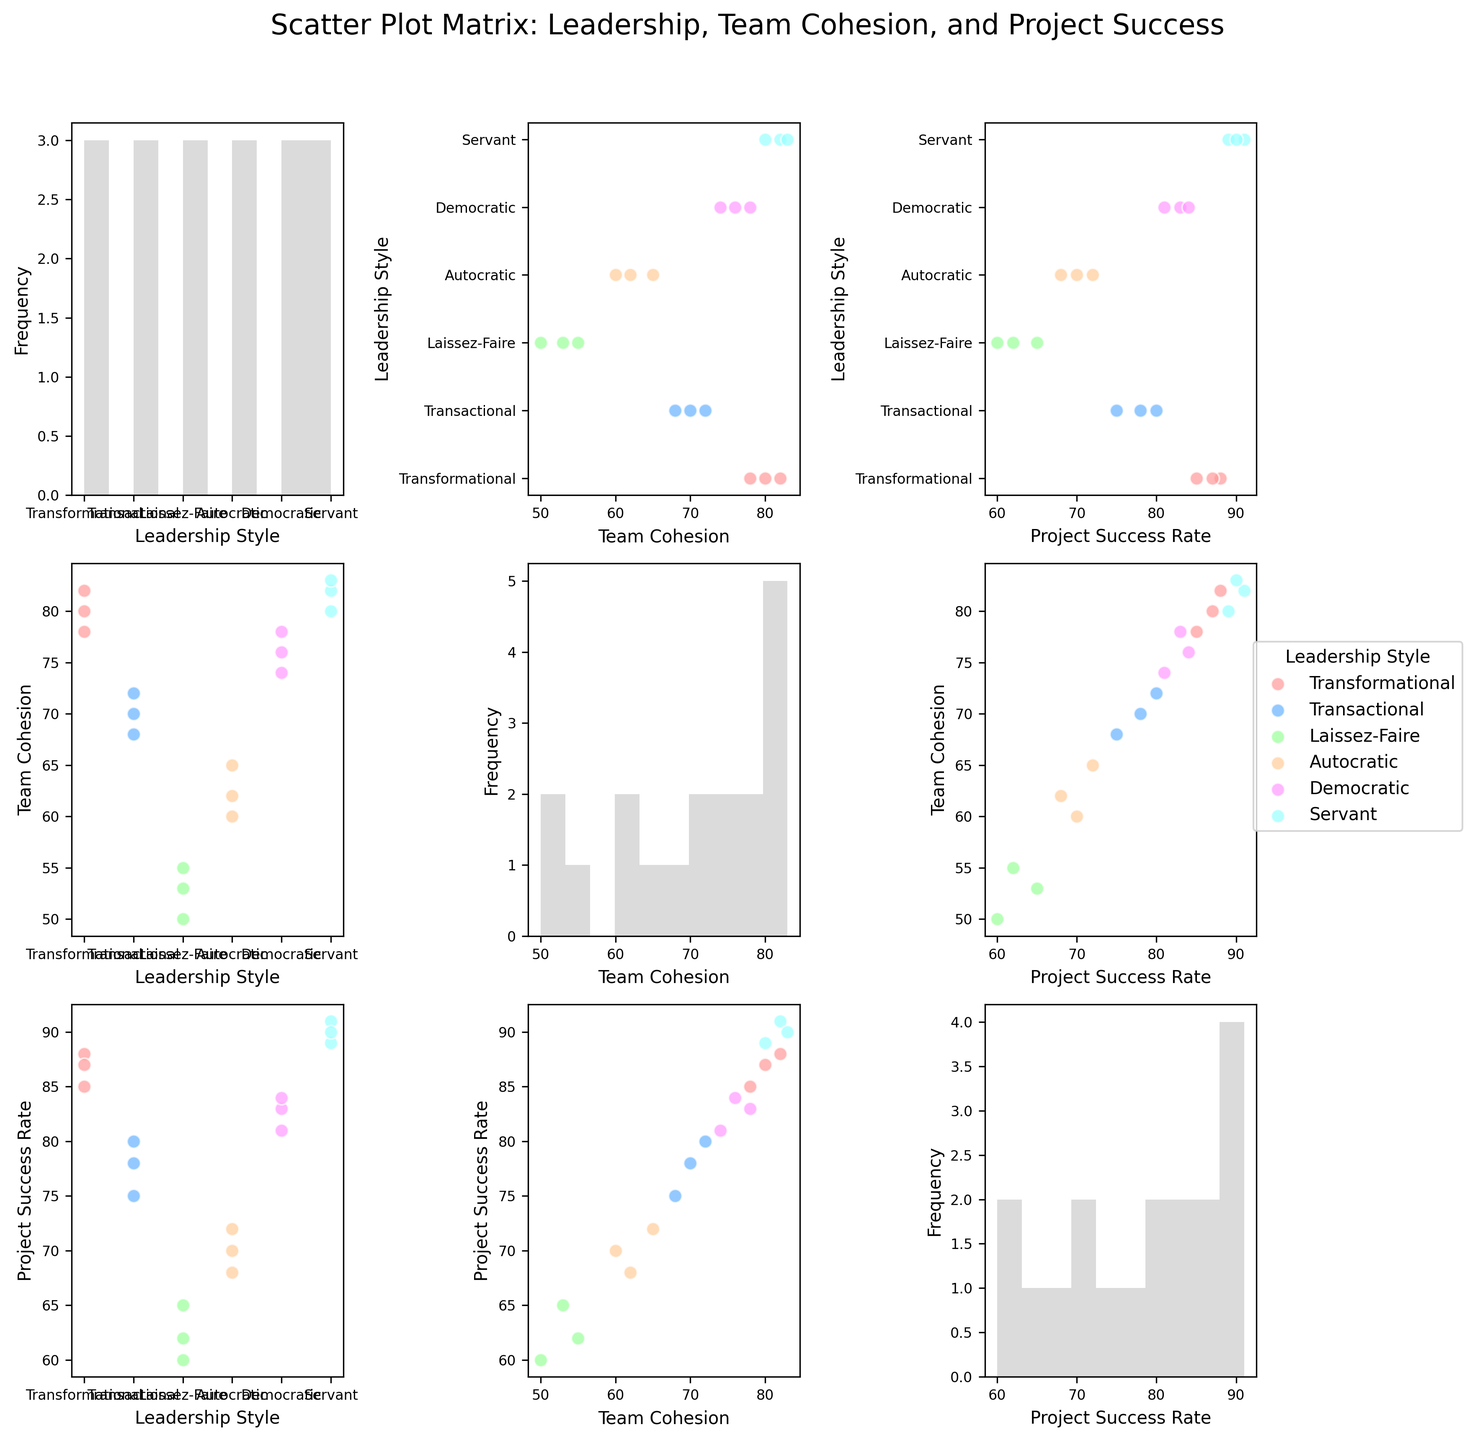What is the title of the figure? The title is displayed at the top of the figure.
Answer: Scatter Plot Matrix: Leadership, Team Cohesion, and Project Success How many leadership styles are represented in the figure? By looking at the legend on the right side of the figure, we can count the different leadership styles.
Answer: Six Which leadership style has the highest range of team cohesion scores? By observing the scatter plots for team cohesion scores across different leadership styles, compare the ranges.
Answer: Transformational Which leadership style has the lowest average project success rate? Check the scatter plots for project success rates and compare the averages for each leadership style.
Answer: Laissez-Faire What is the relationship between team cohesion and project success rate for Servant leadership style? Look at the scatter plot where team cohesion and project success rate are plotted for the Servant leadership style; identify any trends or relationships.
Answer: Positive correlation Is there a higher variability in team cohesion or project success rate for the Autocratic leadership style? Compare the spread of data points for Autocratic leadership in the scatter plots for team cohesion and project success rate respectively.
Answer: Team cohesion Which leadership style appears to have the highest project success rate overall? Check the scatter plots for project success rate and identify the leadership style with the highest data points.
Answer: Servant Among Democratic and Transactional leadership styles, which one shows higher team cohesion scores? Compare the scatter plots for team cohesion scores for Democratic and Transactional styles.
Answer: Democratic Which leadership style shows no overlap with others in terms of team cohesion and project success rate? Compare the scatter plots for team cohesion versus project success rate across all leadership styles to check for overlaps.
Answer: Servant What general pattern can be observed between team cohesion and project success rate across all leadership styles? Look at the scatter plots for team cohesion versus project success rate for all styles and observe the overall trend.
Answer: Positive correlation 